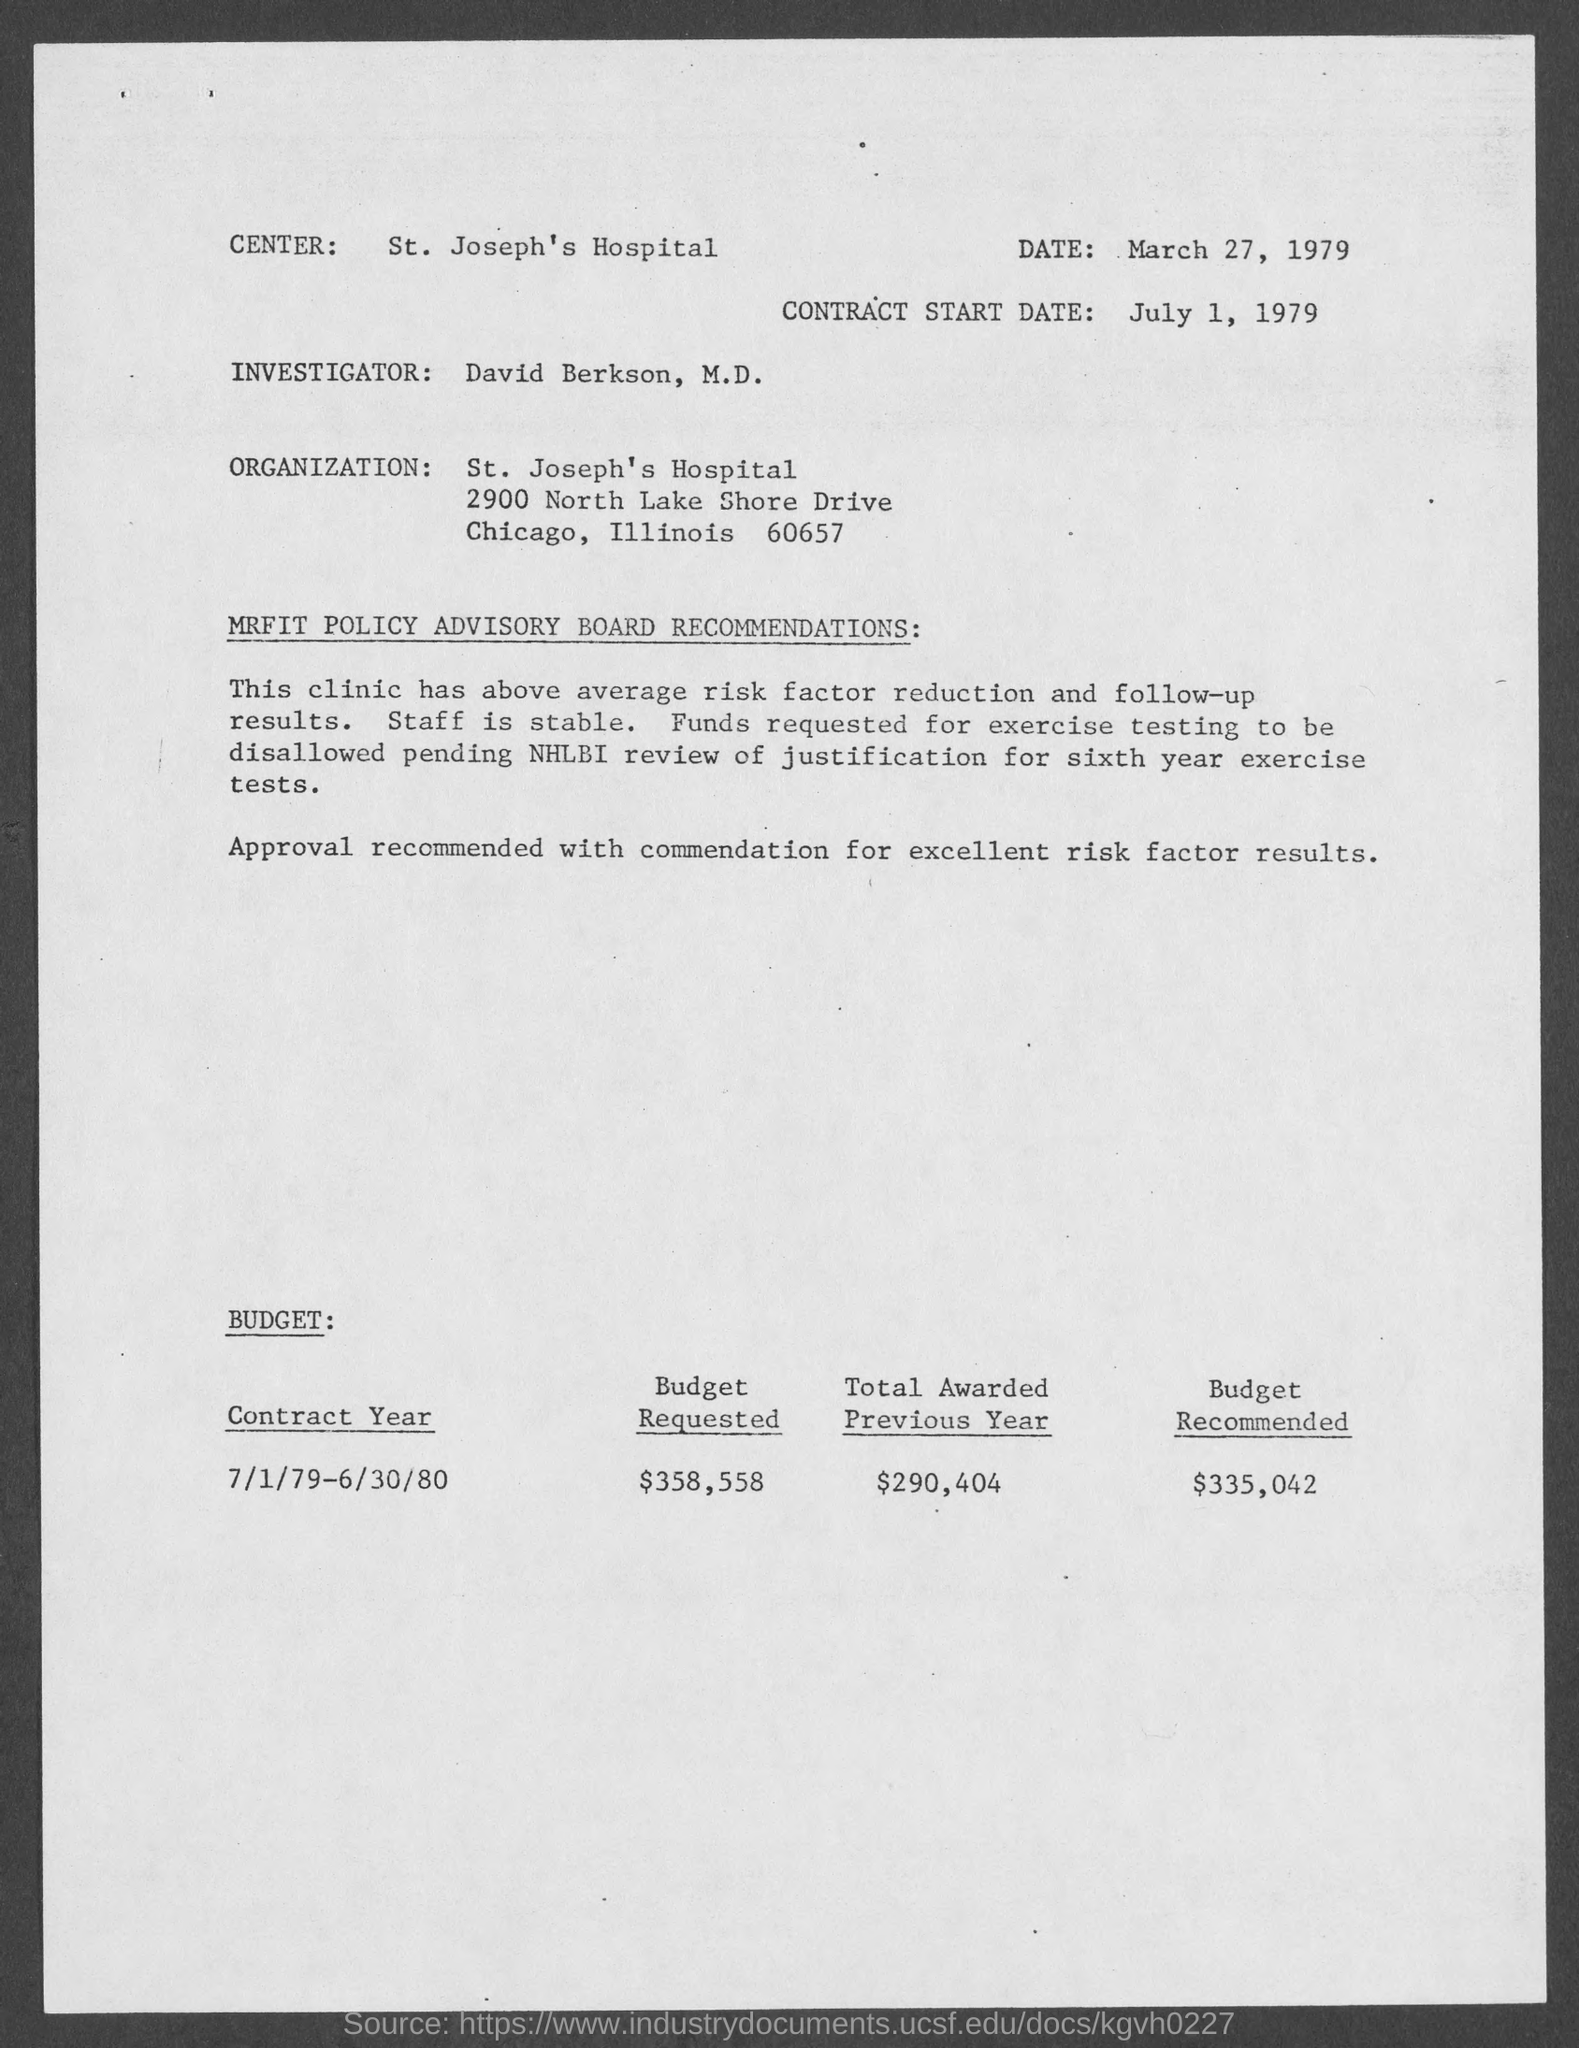What is the date mentioned in the given page ?
Keep it short and to the point. March 27, 1979. What is the contract start date mentioned in the given page ?
Provide a succinct answer. July 1, 1979. What is the name of the center mentioned in the given page ?
Provide a succinct answer. St. joseph's hospital. What is the name of the organization mentioned in the given page ?
Make the answer very short. St. Joseph's Hospital. What is the amount of budget recommended as mentioned in the given page ?
Ensure brevity in your answer.  $335,042. What is the amount of budget requested as mentioned in the given page ?
Offer a very short reply. $358,558. What is the amount of total awarded previous year as mentioned in the given page ?
Ensure brevity in your answer.  $290,404. 